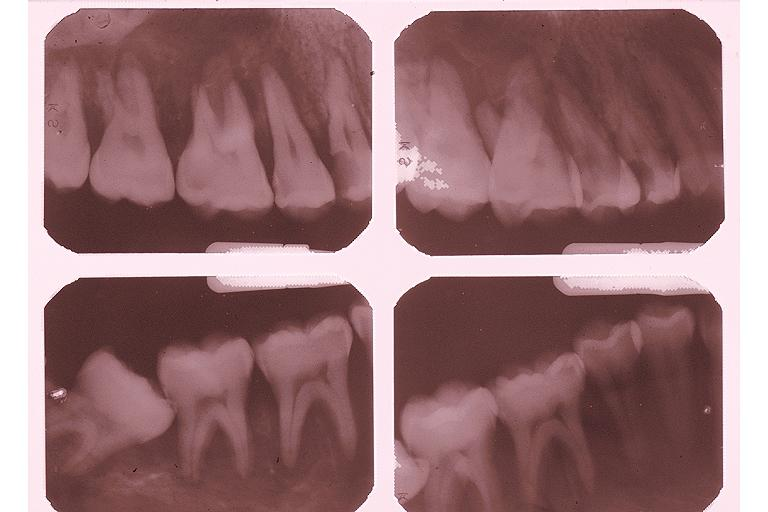s oral present?
Answer the question using a single word or phrase. Yes 